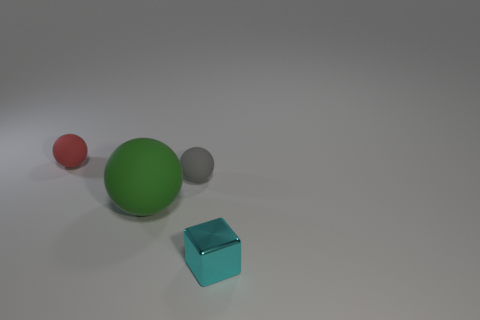Add 4 red rubber balls. How many objects exist? 8 Subtract all tiny balls. How many balls are left? 1 Add 3 small metal objects. How many small metal objects exist? 4 Subtract all gray spheres. How many spheres are left? 2 Subtract 0 red blocks. How many objects are left? 4 Subtract all spheres. How many objects are left? 1 Subtract 1 blocks. How many blocks are left? 0 Subtract all cyan balls. Subtract all yellow cylinders. How many balls are left? 3 Subtract all yellow cubes. How many cyan balls are left? 0 Subtract all large brown metal balls. Subtract all tiny cyan cubes. How many objects are left? 3 